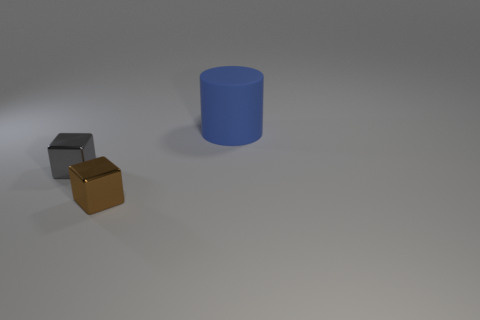Add 2 big green metallic objects. How many objects exist? 5 Subtract all gray blocks. How many blocks are left? 1 Subtract 1 cylinders. How many cylinders are left? 0 Subtract all small red shiny cubes. Subtract all large rubber cylinders. How many objects are left? 2 Add 2 metallic objects. How many metallic objects are left? 4 Add 1 small cyan rubber cubes. How many small cyan rubber cubes exist? 1 Subtract 0 green cubes. How many objects are left? 3 Subtract all cylinders. How many objects are left? 2 Subtract all red cylinders. Subtract all brown cubes. How many cylinders are left? 1 